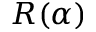Convert formula to latex. <formula><loc_0><loc_0><loc_500><loc_500>R ( \alpha )</formula> 